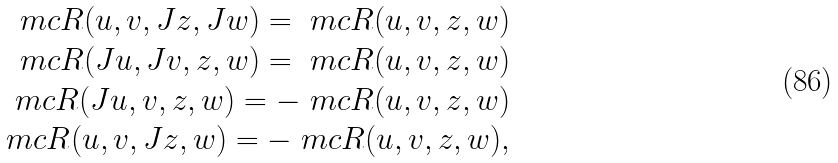Convert formula to latex. <formula><loc_0><loc_0><loc_500><loc_500>\ m c { R } ( u , v , J z , J w ) = \ m c { R } ( u , v , z , w ) \\ \ m c { R } ( J u , J v , z , w ) = \ m c { R } ( u , v , z , w ) \\ \ m c { R } ( J u , v , z , w ) = - \ m c { R } ( u , v , z , w ) \\ \ m c { R } ( u , v , J z , w ) = - \ m c { R } ( u , v , z , w ) ,</formula> 